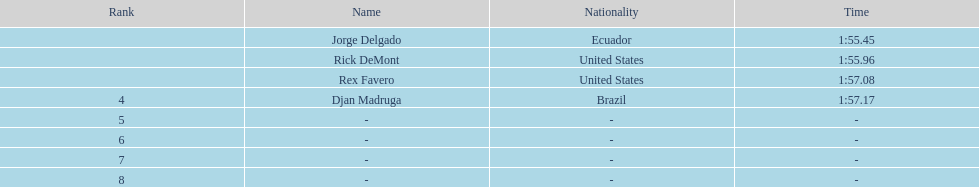What was the following time when favero ended with 1:5 1:57.17. 